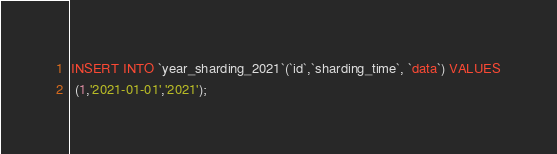<code> <loc_0><loc_0><loc_500><loc_500><_SQL_>INSERT INTO `year_sharding_2021`(`id`,`sharding_time`, `data`) VALUES
 (1,'2021-01-01','2021');</code> 